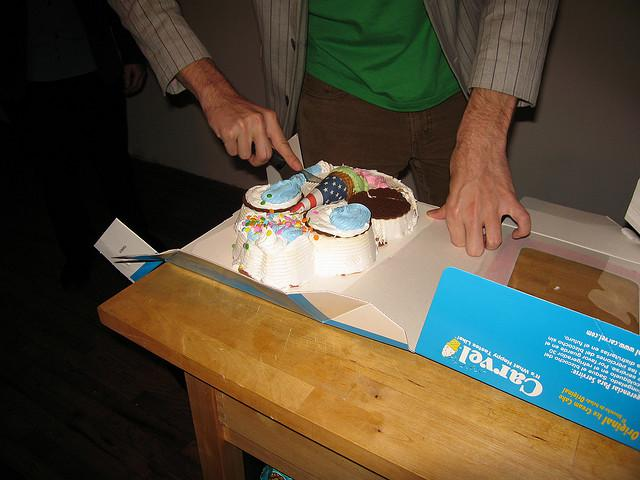What cool treat can be found inside this cake?

Choices:
A) ice cream
B) ice
C) nothing
D) lava ice cream 